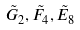<formula> <loc_0><loc_0><loc_500><loc_500>\tilde { G } _ { 2 } , \tilde { F } _ { 4 } , \tilde { E } _ { 8 }</formula> 